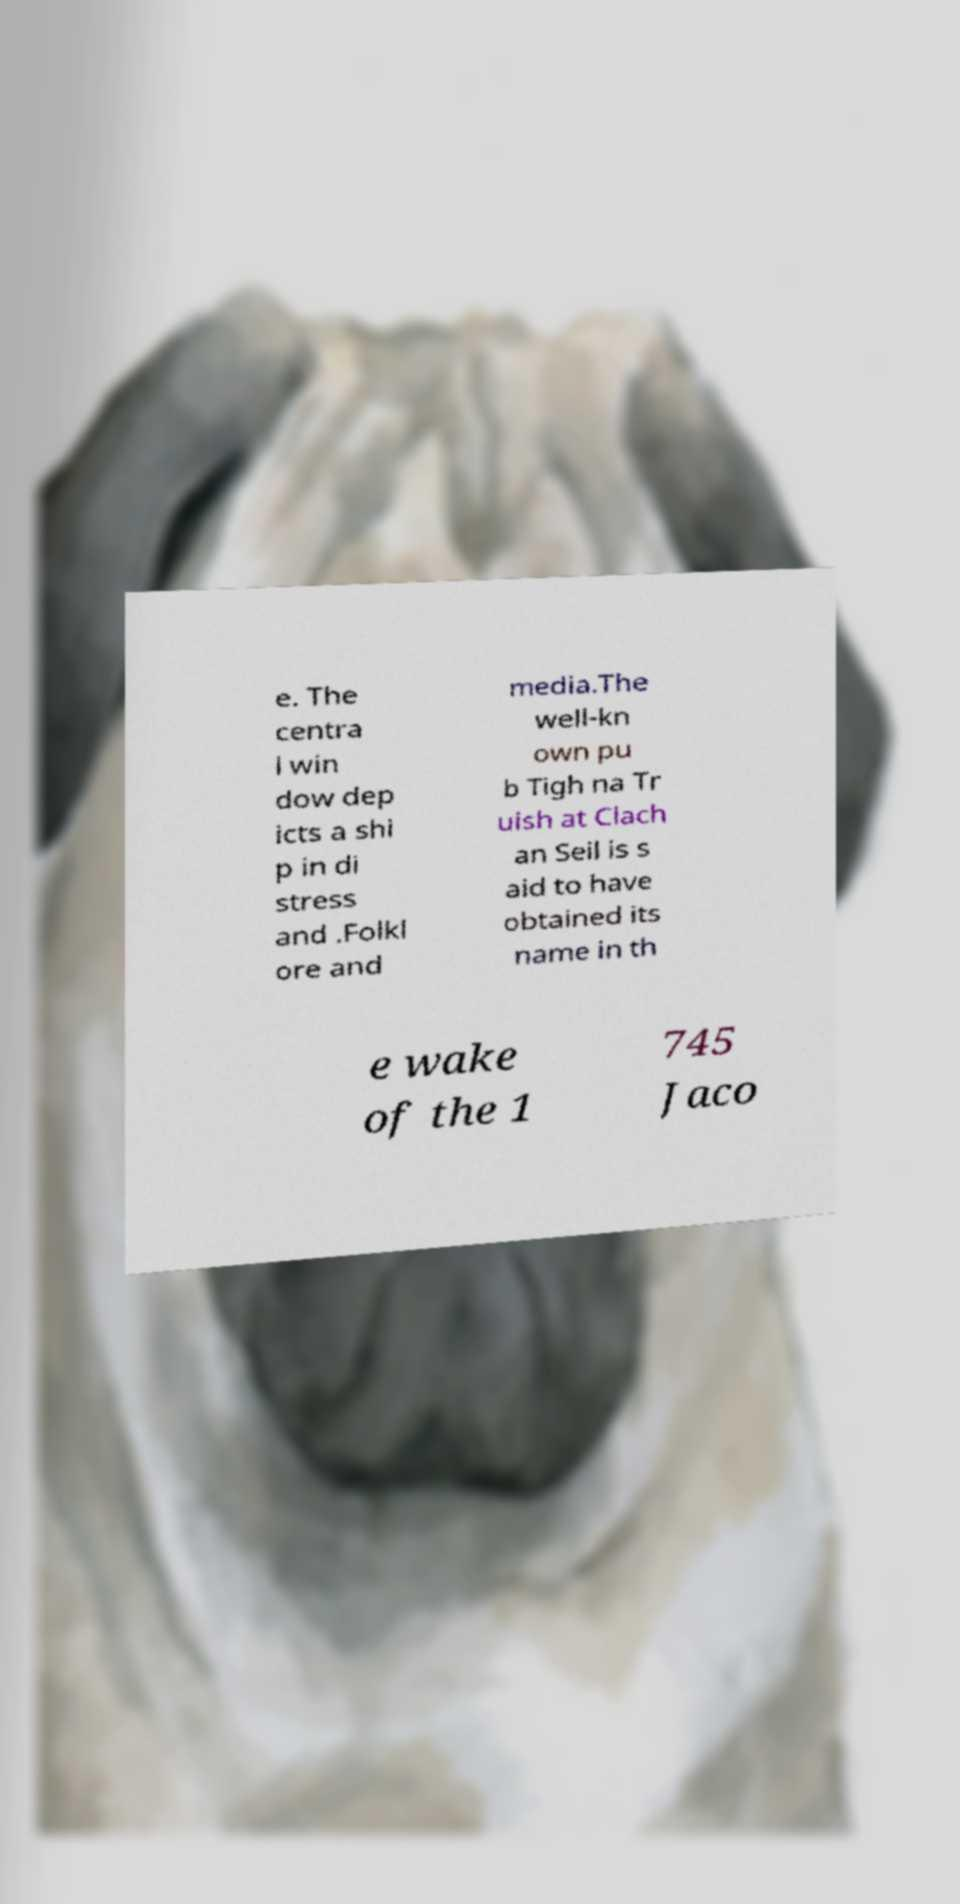Could you extract and type out the text from this image? e. The centra l win dow dep icts a shi p in di stress and .Folkl ore and media.The well-kn own pu b Tigh na Tr uish at Clach an Seil is s aid to have obtained its name in th e wake of the 1 745 Jaco 